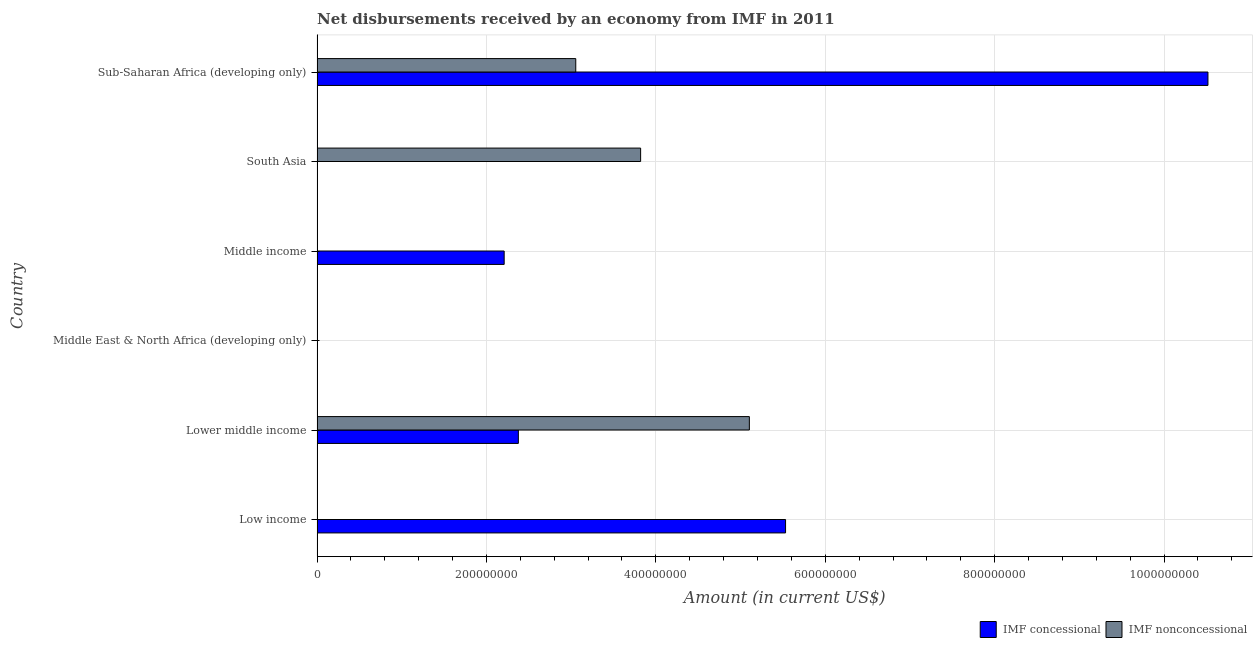Are the number of bars on each tick of the Y-axis equal?
Give a very brief answer. No. How many bars are there on the 5th tick from the top?
Offer a very short reply. 2. What is the label of the 5th group of bars from the top?
Your response must be concise. Lower middle income. In how many cases, is the number of bars for a given country not equal to the number of legend labels?
Keep it short and to the point. 4. What is the net concessional disbursements from imf in Middle East & North Africa (developing only)?
Ensure brevity in your answer.  0. Across all countries, what is the maximum net concessional disbursements from imf?
Make the answer very short. 1.05e+09. In which country was the net non concessional disbursements from imf maximum?
Your answer should be very brief. Lower middle income. What is the total net non concessional disbursements from imf in the graph?
Provide a succinct answer. 1.20e+09. What is the difference between the net concessional disbursements from imf in Low income and that in Middle income?
Give a very brief answer. 3.32e+08. What is the difference between the net non concessional disbursements from imf in South Asia and the net concessional disbursements from imf in Middle income?
Provide a succinct answer. 1.61e+08. What is the average net non concessional disbursements from imf per country?
Your response must be concise. 2.00e+08. What is the difference between the net concessional disbursements from imf and net non concessional disbursements from imf in Lower middle income?
Make the answer very short. -2.73e+08. In how many countries, is the net concessional disbursements from imf greater than 360000000 US$?
Make the answer very short. 2. What is the ratio of the net concessional disbursements from imf in Low income to that in Lower middle income?
Ensure brevity in your answer.  2.33. Is the net concessional disbursements from imf in Lower middle income less than that in Sub-Saharan Africa (developing only)?
Your answer should be compact. Yes. What is the difference between the highest and the second highest net concessional disbursements from imf?
Your answer should be very brief. 4.99e+08. What is the difference between the highest and the lowest net non concessional disbursements from imf?
Make the answer very short. 5.10e+08. Is the sum of the net concessional disbursements from imf in Lower middle income and Sub-Saharan Africa (developing only) greater than the maximum net non concessional disbursements from imf across all countries?
Provide a short and direct response. Yes. Are all the bars in the graph horizontal?
Your answer should be compact. Yes. How many countries are there in the graph?
Offer a very short reply. 6. Does the graph contain grids?
Provide a succinct answer. Yes. Where does the legend appear in the graph?
Your answer should be compact. Bottom right. How are the legend labels stacked?
Keep it short and to the point. Horizontal. What is the title of the graph?
Give a very brief answer. Net disbursements received by an economy from IMF in 2011. Does "Adolescent fertility rate" appear as one of the legend labels in the graph?
Offer a terse response. No. What is the label or title of the X-axis?
Provide a short and direct response. Amount (in current US$). What is the Amount (in current US$) of IMF concessional in Low income?
Keep it short and to the point. 5.53e+08. What is the Amount (in current US$) in IMF concessional in Lower middle income?
Your answer should be compact. 2.38e+08. What is the Amount (in current US$) of IMF nonconcessional in Lower middle income?
Give a very brief answer. 5.10e+08. What is the Amount (in current US$) in IMF concessional in Middle East & North Africa (developing only)?
Your answer should be compact. 0. What is the Amount (in current US$) in IMF nonconcessional in Middle East & North Africa (developing only)?
Provide a short and direct response. 0. What is the Amount (in current US$) of IMF concessional in Middle income?
Your answer should be very brief. 2.21e+08. What is the Amount (in current US$) of IMF nonconcessional in Middle income?
Provide a short and direct response. 0. What is the Amount (in current US$) of IMF concessional in South Asia?
Give a very brief answer. 0. What is the Amount (in current US$) of IMF nonconcessional in South Asia?
Your answer should be compact. 3.82e+08. What is the Amount (in current US$) of IMF concessional in Sub-Saharan Africa (developing only)?
Offer a very short reply. 1.05e+09. What is the Amount (in current US$) of IMF nonconcessional in Sub-Saharan Africa (developing only)?
Your answer should be very brief. 3.05e+08. Across all countries, what is the maximum Amount (in current US$) of IMF concessional?
Provide a succinct answer. 1.05e+09. Across all countries, what is the maximum Amount (in current US$) in IMF nonconcessional?
Your answer should be very brief. 5.10e+08. Across all countries, what is the minimum Amount (in current US$) of IMF nonconcessional?
Your response must be concise. 0. What is the total Amount (in current US$) of IMF concessional in the graph?
Provide a short and direct response. 2.06e+09. What is the total Amount (in current US$) of IMF nonconcessional in the graph?
Offer a terse response. 1.20e+09. What is the difference between the Amount (in current US$) of IMF concessional in Low income and that in Lower middle income?
Your response must be concise. 3.15e+08. What is the difference between the Amount (in current US$) in IMF concessional in Low income and that in Middle income?
Make the answer very short. 3.32e+08. What is the difference between the Amount (in current US$) in IMF concessional in Low income and that in Sub-Saharan Africa (developing only)?
Your answer should be compact. -4.99e+08. What is the difference between the Amount (in current US$) in IMF concessional in Lower middle income and that in Middle income?
Offer a very short reply. 1.68e+07. What is the difference between the Amount (in current US$) in IMF nonconcessional in Lower middle income and that in South Asia?
Provide a short and direct response. 1.28e+08. What is the difference between the Amount (in current US$) in IMF concessional in Lower middle income and that in Sub-Saharan Africa (developing only)?
Offer a very short reply. -8.14e+08. What is the difference between the Amount (in current US$) in IMF nonconcessional in Lower middle income and that in Sub-Saharan Africa (developing only)?
Keep it short and to the point. 2.05e+08. What is the difference between the Amount (in current US$) of IMF concessional in Middle income and that in Sub-Saharan Africa (developing only)?
Provide a short and direct response. -8.31e+08. What is the difference between the Amount (in current US$) in IMF nonconcessional in South Asia and that in Sub-Saharan Africa (developing only)?
Offer a terse response. 7.66e+07. What is the difference between the Amount (in current US$) in IMF concessional in Low income and the Amount (in current US$) in IMF nonconcessional in Lower middle income?
Offer a very short reply. 4.27e+07. What is the difference between the Amount (in current US$) in IMF concessional in Low income and the Amount (in current US$) in IMF nonconcessional in South Asia?
Provide a short and direct response. 1.71e+08. What is the difference between the Amount (in current US$) in IMF concessional in Low income and the Amount (in current US$) in IMF nonconcessional in Sub-Saharan Africa (developing only)?
Make the answer very short. 2.48e+08. What is the difference between the Amount (in current US$) of IMF concessional in Lower middle income and the Amount (in current US$) of IMF nonconcessional in South Asia?
Provide a short and direct response. -1.44e+08. What is the difference between the Amount (in current US$) of IMF concessional in Lower middle income and the Amount (in current US$) of IMF nonconcessional in Sub-Saharan Africa (developing only)?
Ensure brevity in your answer.  -6.78e+07. What is the difference between the Amount (in current US$) of IMF concessional in Middle income and the Amount (in current US$) of IMF nonconcessional in South Asia?
Offer a very short reply. -1.61e+08. What is the difference between the Amount (in current US$) of IMF concessional in Middle income and the Amount (in current US$) of IMF nonconcessional in Sub-Saharan Africa (developing only)?
Your answer should be very brief. -8.45e+07. What is the average Amount (in current US$) of IMF concessional per country?
Ensure brevity in your answer.  3.44e+08. What is the average Amount (in current US$) of IMF nonconcessional per country?
Your response must be concise. 2.00e+08. What is the difference between the Amount (in current US$) of IMF concessional and Amount (in current US$) of IMF nonconcessional in Lower middle income?
Provide a short and direct response. -2.73e+08. What is the difference between the Amount (in current US$) of IMF concessional and Amount (in current US$) of IMF nonconcessional in Sub-Saharan Africa (developing only)?
Ensure brevity in your answer.  7.46e+08. What is the ratio of the Amount (in current US$) of IMF concessional in Low income to that in Lower middle income?
Offer a very short reply. 2.33. What is the ratio of the Amount (in current US$) of IMF concessional in Low income to that in Middle income?
Ensure brevity in your answer.  2.5. What is the ratio of the Amount (in current US$) of IMF concessional in Low income to that in Sub-Saharan Africa (developing only)?
Offer a terse response. 0.53. What is the ratio of the Amount (in current US$) of IMF concessional in Lower middle income to that in Middle income?
Provide a succinct answer. 1.08. What is the ratio of the Amount (in current US$) in IMF nonconcessional in Lower middle income to that in South Asia?
Your response must be concise. 1.34. What is the ratio of the Amount (in current US$) of IMF concessional in Lower middle income to that in Sub-Saharan Africa (developing only)?
Give a very brief answer. 0.23. What is the ratio of the Amount (in current US$) of IMF nonconcessional in Lower middle income to that in Sub-Saharan Africa (developing only)?
Ensure brevity in your answer.  1.67. What is the ratio of the Amount (in current US$) in IMF concessional in Middle income to that in Sub-Saharan Africa (developing only)?
Your response must be concise. 0.21. What is the ratio of the Amount (in current US$) of IMF nonconcessional in South Asia to that in Sub-Saharan Africa (developing only)?
Offer a very short reply. 1.25. What is the difference between the highest and the second highest Amount (in current US$) in IMF concessional?
Provide a short and direct response. 4.99e+08. What is the difference between the highest and the second highest Amount (in current US$) in IMF nonconcessional?
Offer a very short reply. 1.28e+08. What is the difference between the highest and the lowest Amount (in current US$) in IMF concessional?
Your answer should be compact. 1.05e+09. What is the difference between the highest and the lowest Amount (in current US$) of IMF nonconcessional?
Your answer should be very brief. 5.10e+08. 